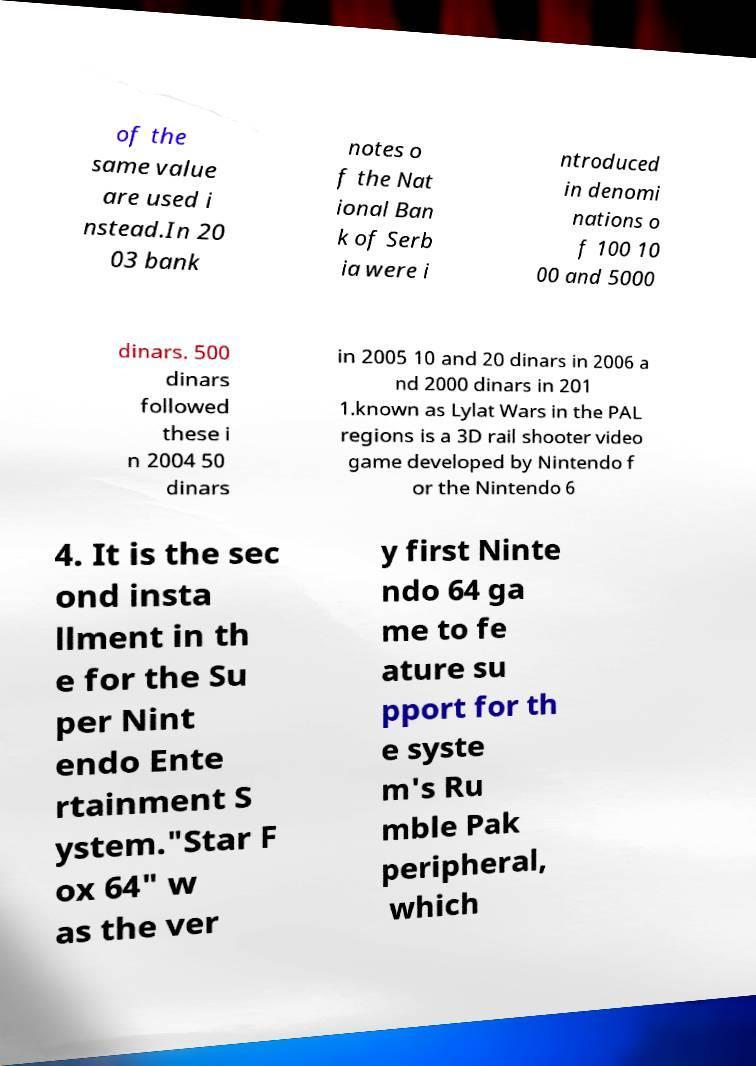Could you assist in decoding the text presented in this image and type it out clearly? of the same value are used i nstead.In 20 03 bank notes o f the Nat ional Ban k of Serb ia were i ntroduced in denomi nations o f 100 10 00 and 5000 dinars. 500 dinars followed these i n 2004 50 dinars in 2005 10 and 20 dinars in 2006 a nd 2000 dinars in 201 1.known as Lylat Wars in the PAL regions is a 3D rail shooter video game developed by Nintendo f or the Nintendo 6 4. It is the sec ond insta llment in th e for the Su per Nint endo Ente rtainment S ystem."Star F ox 64" w as the ver y first Ninte ndo 64 ga me to fe ature su pport for th e syste m's Ru mble Pak peripheral, which 